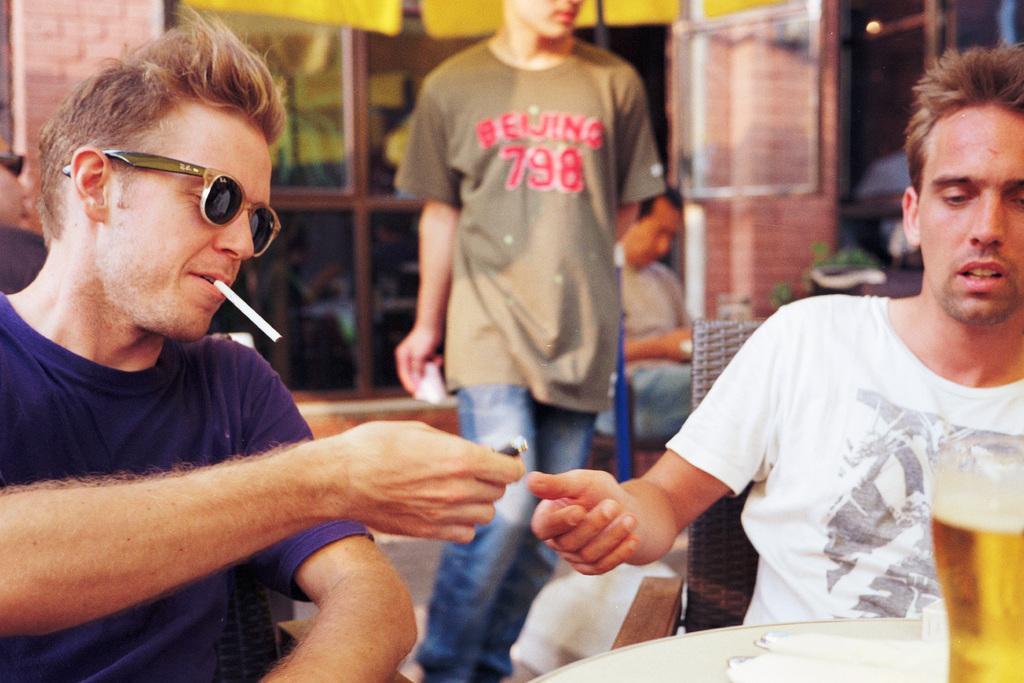Please provide a concise description of this image. In the image in the center we can see two people were sitting on the chair. And the left side person is holding lighter. In front of them,there is a table. On the table,we can see one wine glass and few other objects. In the background there is a wall,glass,one person standing and few people were sitting. 